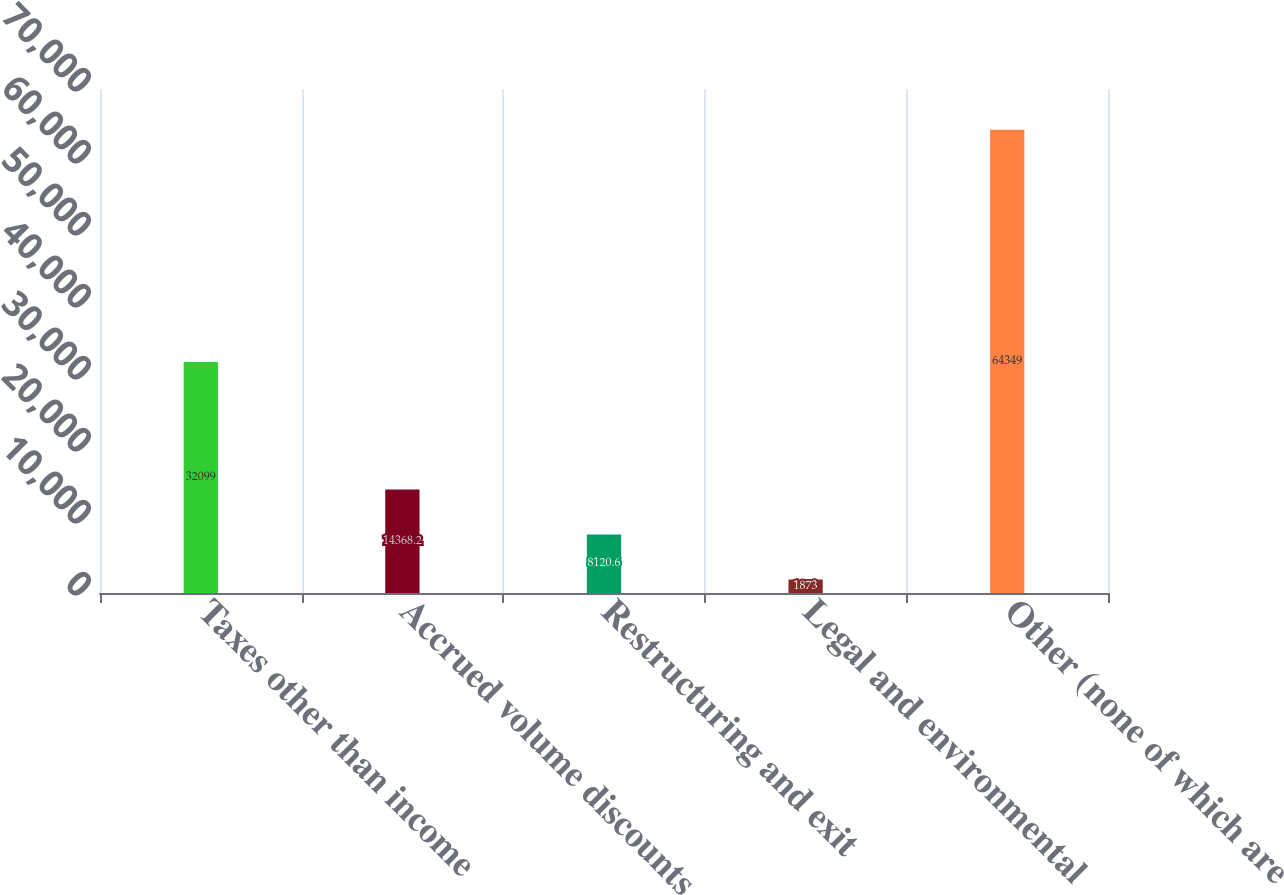Convert chart. <chart><loc_0><loc_0><loc_500><loc_500><bar_chart><fcel>Taxes other than income<fcel>Accrued volume discounts<fcel>Restructuring and exit<fcel>Legal and environmental<fcel>Other (none of which are<nl><fcel>32099<fcel>14368.2<fcel>8120.6<fcel>1873<fcel>64349<nl></chart> 